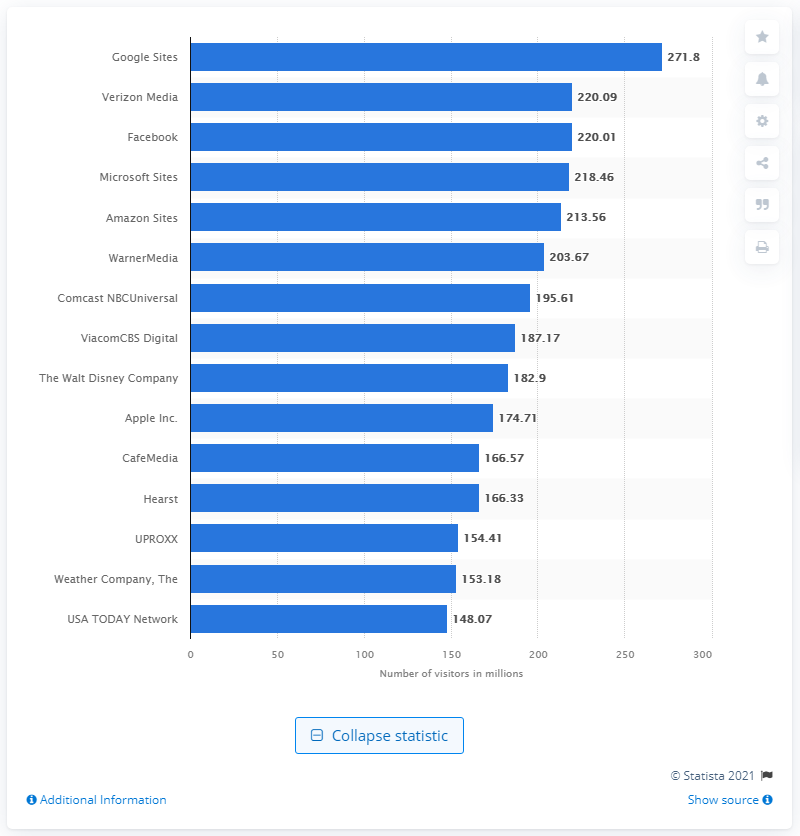Highlight a few significant elements in this photo. According to multi-platform audience data, Facebook is the most popular social network in the United States. According to data from April 2021, Google Sites was ranked as the most popular multiplatform web property in the United States. In April 2021, 271.8 people visited Google Sites. 